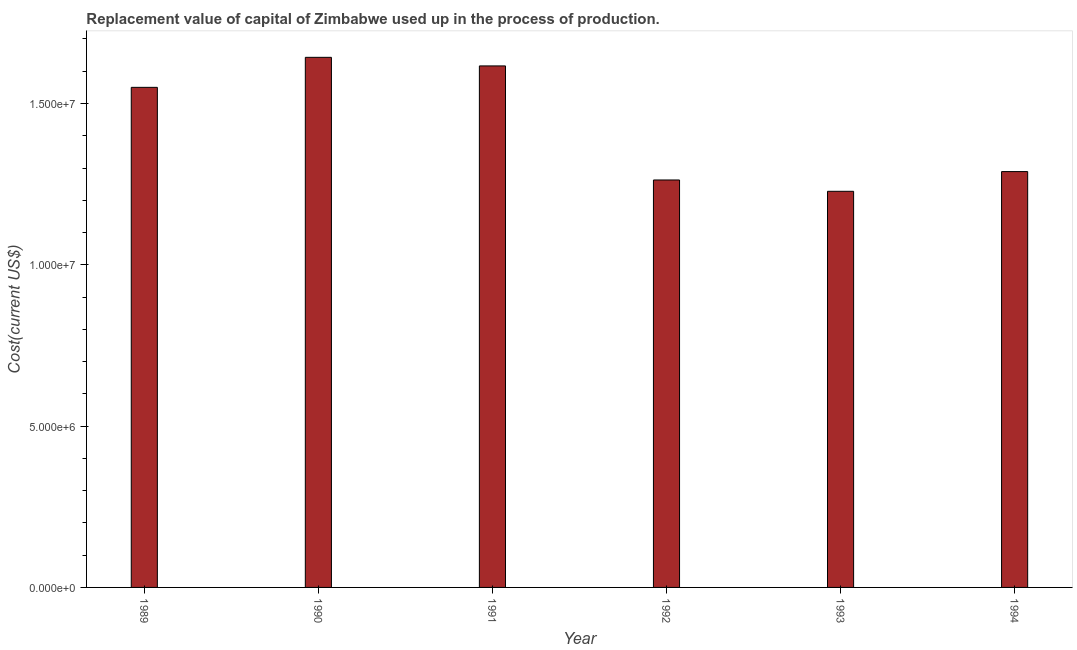Does the graph contain grids?
Offer a terse response. No. What is the title of the graph?
Your response must be concise. Replacement value of capital of Zimbabwe used up in the process of production. What is the label or title of the Y-axis?
Your answer should be compact. Cost(current US$). What is the consumption of fixed capital in 1992?
Your response must be concise. 1.26e+07. Across all years, what is the maximum consumption of fixed capital?
Offer a terse response. 1.64e+07. Across all years, what is the minimum consumption of fixed capital?
Give a very brief answer. 1.23e+07. In which year was the consumption of fixed capital maximum?
Keep it short and to the point. 1990. In which year was the consumption of fixed capital minimum?
Give a very brief answer. 1993. What is the sum of the consumption of fixed capital?
Offer a very short reply. 8.59e+07. What is the difference between the consumption of fixed capital in 1989 and 1990?
Your answer should be compact. -9.31e+05. What is the average consumption of fixed capital per year?
Keep it short and to the point. 1.43e+07. What is the median consumption of fixed capital?
Keep it short and to the point. 1.42e+07. Do a majority of the years between 1991 and 1992 (inclusive) have consumption of fixed capital greater than 16000000 US$?
Offer a very short reply. No. What is the ratio of the consumption of fixed capital in 1991 to that in 1993?
Give a very brief answer. 1.32. Is the difference between the consumption of fixed capital in 1992 and 1993 greater than the difference between any two years?
Your response must be concise. No. What is the difference between the highest and the second highest consumption of fixed capital?
Offer a terse response. 2.66e+05. Is the sum of the consumption of fixed capital in 1989 and 1990 greater than the maximum consumption of fixed capital across all years?
Your answer should be very brief. Yes. What is the difference between the highest and the lowest consumption of fixed capital?
Your response must be concise. 4.15e+06. In how many years, is the consumption of fixed capital greater than the average consumption of fixed capital taken over all years?
Your answer should be compact. 3. Are all the bars in the graph horizontal?
Offer a very short reply. No. What is the difference between two consecutive major ticks on the Y-axis?
Provide a short and direct response. 5.00e+06. Are the values on the major ticks of Y-axis written in scientific E-notation?
Your response must be concise. Yes. What is the Cost(current US$) in 1989?
Make the answer very short. 1.55e+07. What is the Cost(current US$) of 1990?
Offer a very short reply. 1.64e+07. What is the Cost(current US$) in 1991?
Offer a terse response. 1.62e+07. What is the Cost(current US$) in 1992?
Ensure brevity in your answer.  1.26e+07. What is the Cost(current US$) in 1993?
Provide a short and direct response. 1.23e+07. What is the Cost(current US$) in 1994?
Ensure brevity in your answer.  1.29e+07. What is the difference between the Cost(current US$) in 1989 and 1990?
Provide a short and direct response. -9.31e+05. What is the difference between the Cost(current US$) in 1989 and 1991?
Keep it short and to the point. -6.64e+05. What is the difference between the Cost(current US$) in 1989 and 1992?
Your answer should be very brief. 2.87e+06. What is the difference between the Cost(current US$) in 1989 and 1993?
Make the answer very short. 3.22e+06. What is the difference between the Cost(current US$) in 1989 and 1994?
Your answer should be very brief. 2.61e+06. What is the difference between the Cost(current US$) in 1990 and 1991?
Offer a very short reply. 2.66e+05. What is the difference between the Cost(current US$) in 1990 and 1992?
Your response must be concise. 3.80e+06. What is the difference between the Cost(current US$) in 1990 and 1993?
Ensure brevity in your answer.  4.15e+06. What is the difference between the Cost(current US$) in 1990 and 1994?
Your answer should be compact. 3.54e+06. What is the difference between the Cost(current US$) in 1991 and 1992?
Your answer should be compact. 3.54e+06. What is the difference between the Cost(current US$) in 1991 and 1993?
Offer a very short reply. 3.89e+06. What is the difference between the Cost(current US$) in 1991 and 1994?
Ensure brevity in your answer.  3.28e+06. What is the difference between the Cost(current US$) in 1992 and 1993?
Keep it short and to the point. 3.51e+05. What is the difference between the Cost(current US$) in 1992 and 1994?
Offer a terse response. -2.60e+05. What is the difference between the Cost(current US$) in 1993 and 1994?
Provide a succinct answer. -6.11e+05. What is the ratio of the Cost(current US$) in 1989 to that in 1990?
Ensure brevity in your answer.  0.94. What is the ratio of the Cost(current US$) in 1989 to that in 1992?
Give a very brief answer. 1.23. What is the ratio of the Cost(current US$) in 1989 to that in 1993?
Your answer should be compact. 1.26. What is the ratio of the Cost(current US$) in 1989 to that in 1994?
Your answer should be very brief. 1.2. What is the ratio of the Cost(current US$) in 1990 to that in 1992?
Offer a terse response. 1.3. What is the ratio of the Cost(current US$) in 1990 to that in 1993?
Give a very brief answer. 1.34. What is the ratio of the Cost(current US$) in 1990 to that in 1994?
Your answer should be compact. 1.27. What is the ratio of the Cost(current US$) in 1991 to that in 1992?
Give a very brief answer. 1.28. What is the ratio of the Cost(current US$) in 1991 to that in 1993?
Keep it short and to the point. 1.32. What is the ratio of the Cost(current US$) in 1991 to that in 1994?
Your response must be concise. 1.25. What is the ratio of the Cost(current US$) in 1992 to that in 1993?
Your answer should be compact. 1.03. What is the ratio of the Cost(current US$) in 1992 to that in 1994?
Offer a very short reply. 0.98. What is the ratio of the Cost(current US$) in 1993 to that in 1994?
Give a very brief answer. 0.95. 